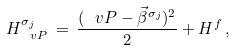Convert formula to latex. <formula><loc_0><loc_0><loc_500><loc_500>H _ { \ v P } ^ { \sigma _ { j } } \, = \, \frac { ( \ v P - \vec { \beta } ^ { \sigma _ { j } } ) ^ { 2 } } { 2 } + H ^ { f } \, ,</formula> 